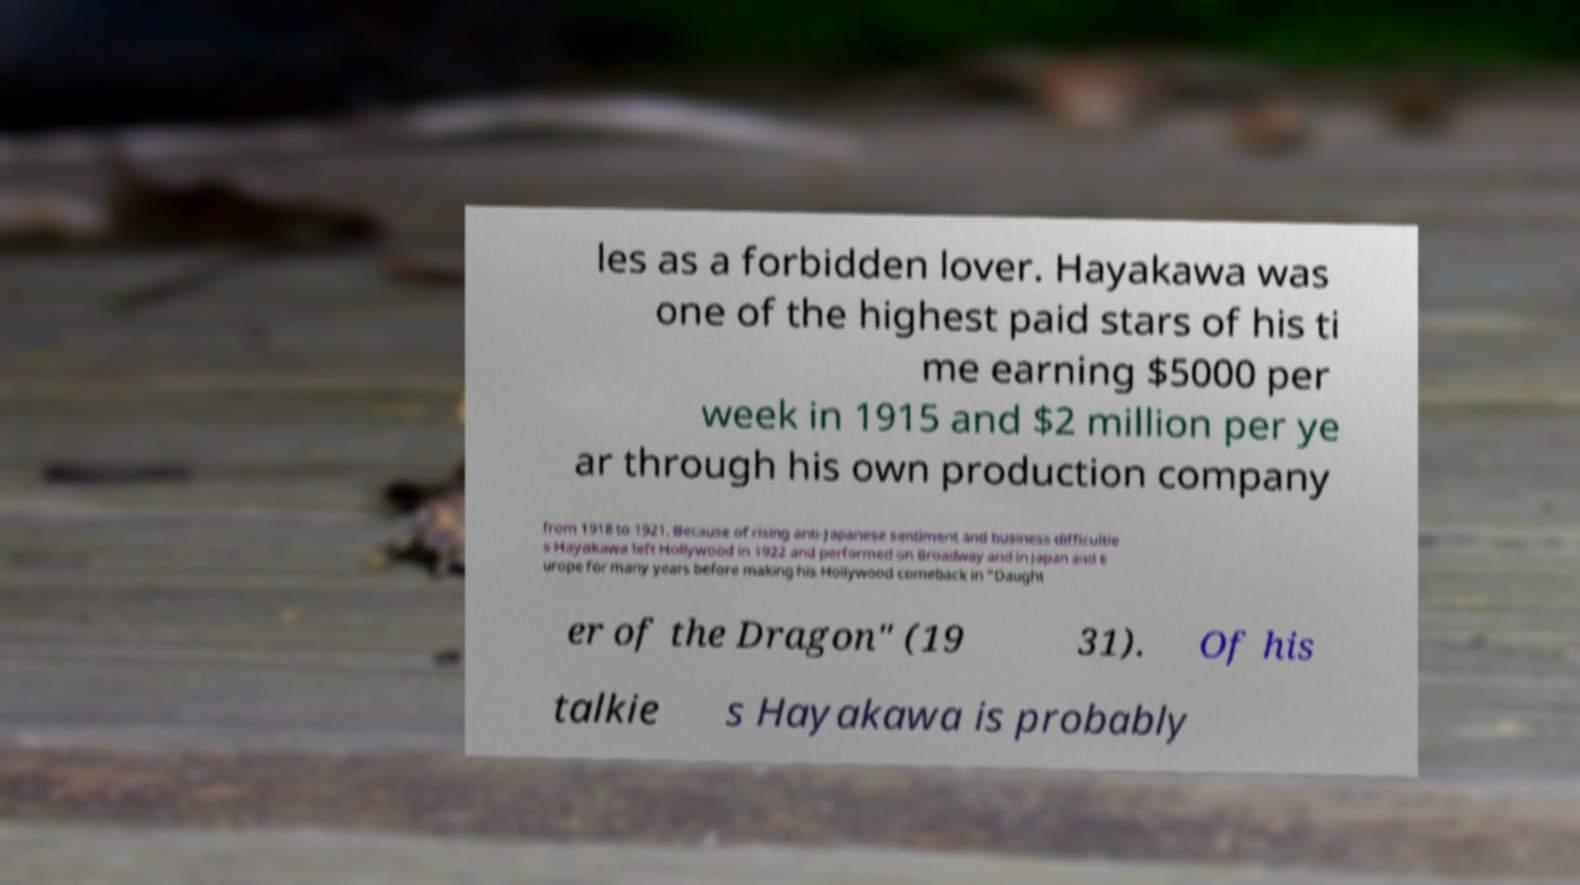Can you accurately transcribe the text from the provided image for me? les as a forbidden lover. Hayakawa was one of the highest paid stars of his ti me earning $5000 per week in 1915 and $2 million per ye ar through his own production company from 1918 to 1921. Because of rising anti-Japanese sentiment and business difficultie s Hayakawa left Hollywood in 1922 and performed on Broadway and in Japan and E urope for many years before making his Hollywood comeback in "Daught er of the Dragon" (19 31). Of his talkie s Hayakawa is probably 